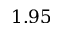Convert formula to latex. <formula><loc_0><loc_0><loc_500><loc_500>1 . 9 5</formula> 